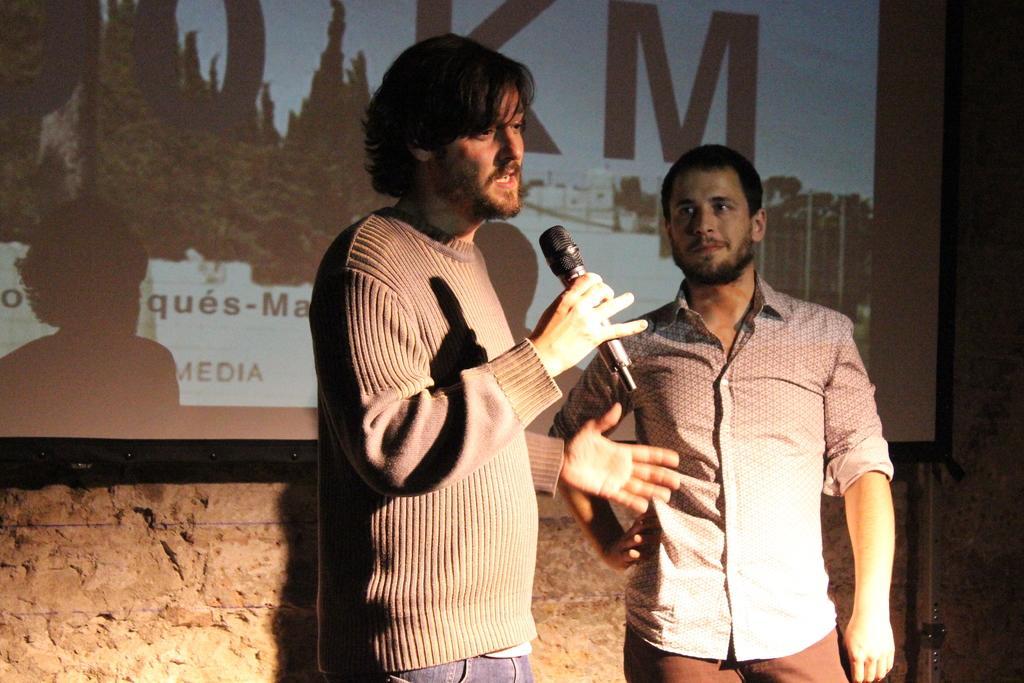How would you summarize this image in a sentence or two? In this image there are two people standing ,And a one man holding a microphone and speaking something and in the background there is a wall on which there is a power point projection. 